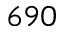Convert formula to latex. <formula><loc_0><loc_0><loc_500><loc_500>6 9 0</formula> 